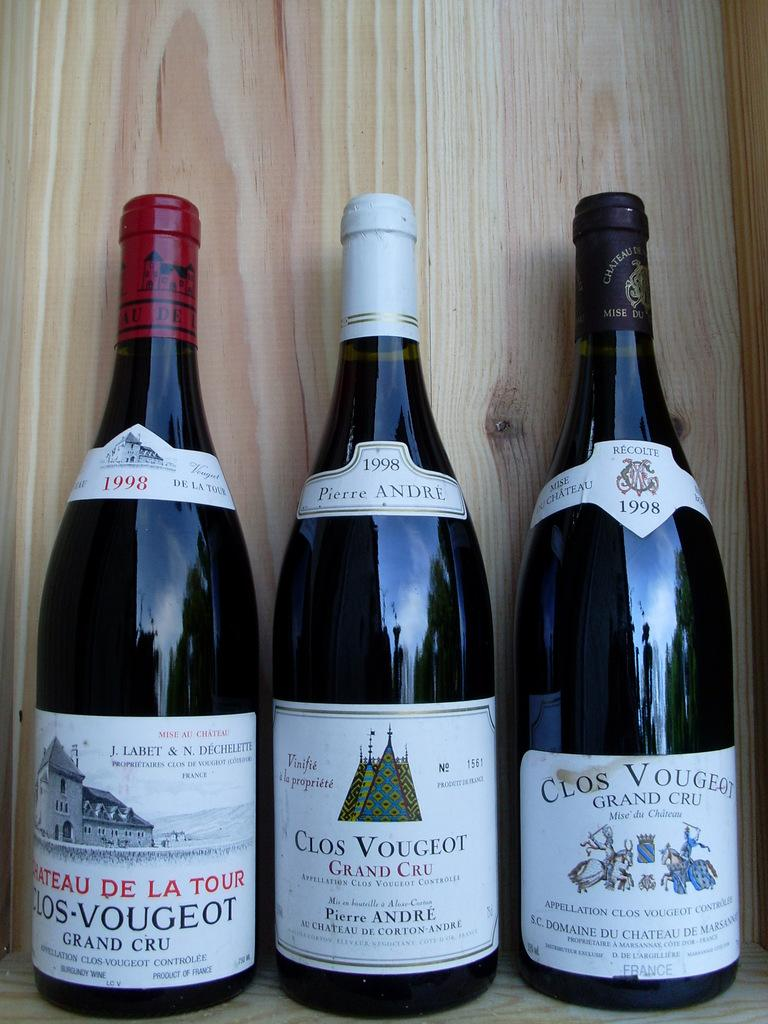<image>
Present a compact description of the photo's key features. Three bottles of wine are displayed side by side. 